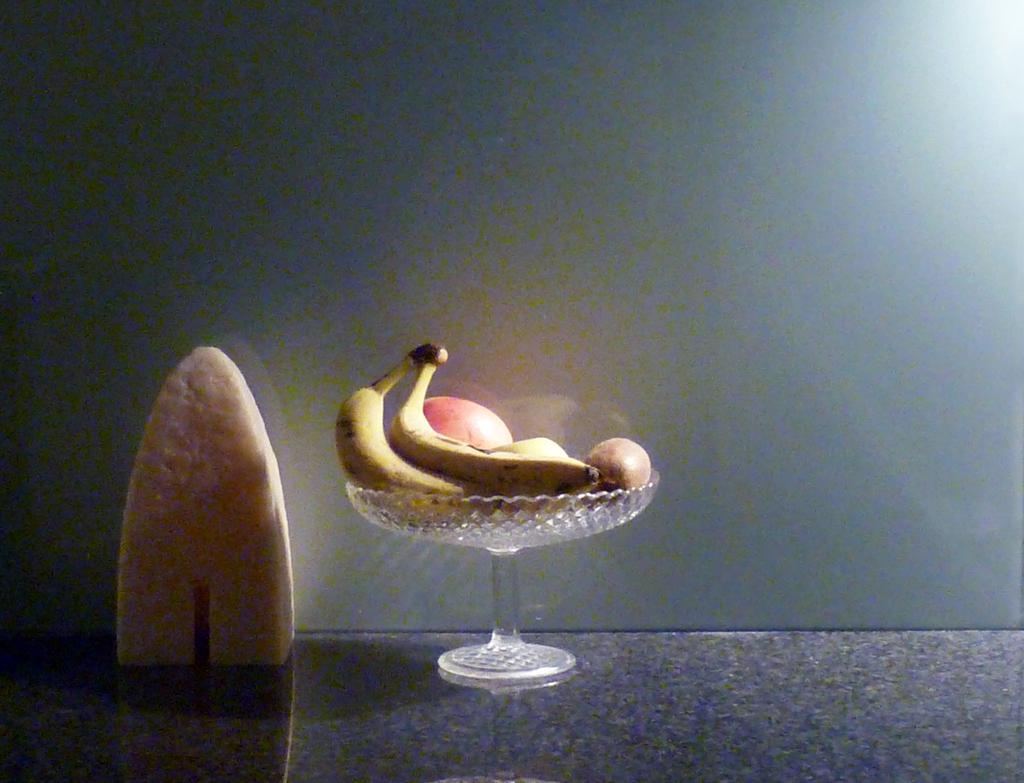Can you describe this image briefly? In the center of the image we can see one table. On the table, we can see one bowl and cream color object. In the bowl, we can see bananas and some other fruits. In the background there is a wall. 